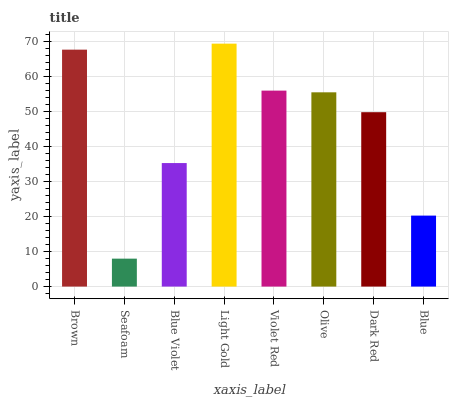Is Seafoam the minimum?
Answer yes or no. Yes. Is Light Gold the maximum?
Answer yes or no. Yes. Is Blue Violet the minimum?
Answer yes or no. No. Is Blue Violet the maximum?
Answer yes or no. No. Is Blue Violet greater than Seafoam?
Answer yes or no. Yes. Is Seafoam less than Blue Violet?
Answer yes or no. Yes. Is Seafoam greater than Blue Violet?
Answer yes or no. No. Is Blue Violet less than Seafoam?
Answer yes or no. No. Is Olive the high median?
Answer yes or no. Yes. Is Dark Red the low median?
Answer yes or no. Yes. Is Brown the high median?
Answer yes or no. No. Is Light Gold the low median?
Answer yes or no. No. 